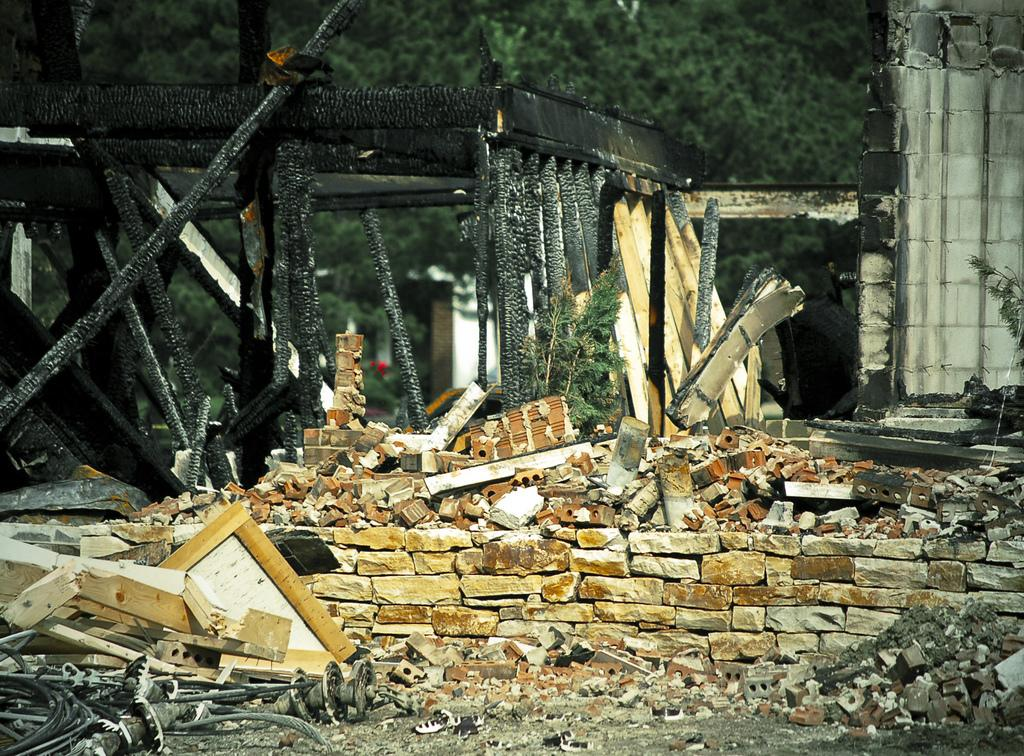What type of building is in the image? There is an old house in the image. What can be seen in the background of the image? There are trees in the image. When was the image taken? The image was taken during the day. What type of produce is being harvested by the friend in the image? There is no friend or produce present in the image; it features an old house and trees. 